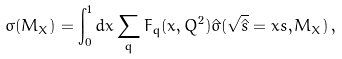<formula> <loc_0><loc_0><loc_500><loc_500>\sigma ( M _ { X } ) = \int _ { 0 } ^ { 1 } d x \sum _ { q } F _ { q } ( x , Q ^ { 2 } ) \hat { \sigma } ( \sqrt { \hat { s } } = x s , M _ { X } ) \, ,</formula> 